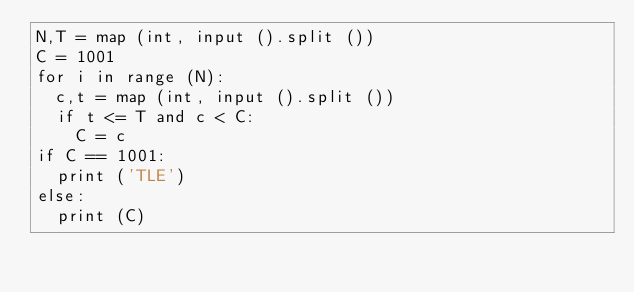<code> <loc_0><loc_0><loc_500><loc_500><_Python_>N,T = map (int, input ().split ())
C = 1001
for i in range (N):
  c,t = map (int, input ().split ())
  if t <= T and c < C:
    C = c
if C == 1001:
  print ('TLE')
else:
  print (C)</code> 